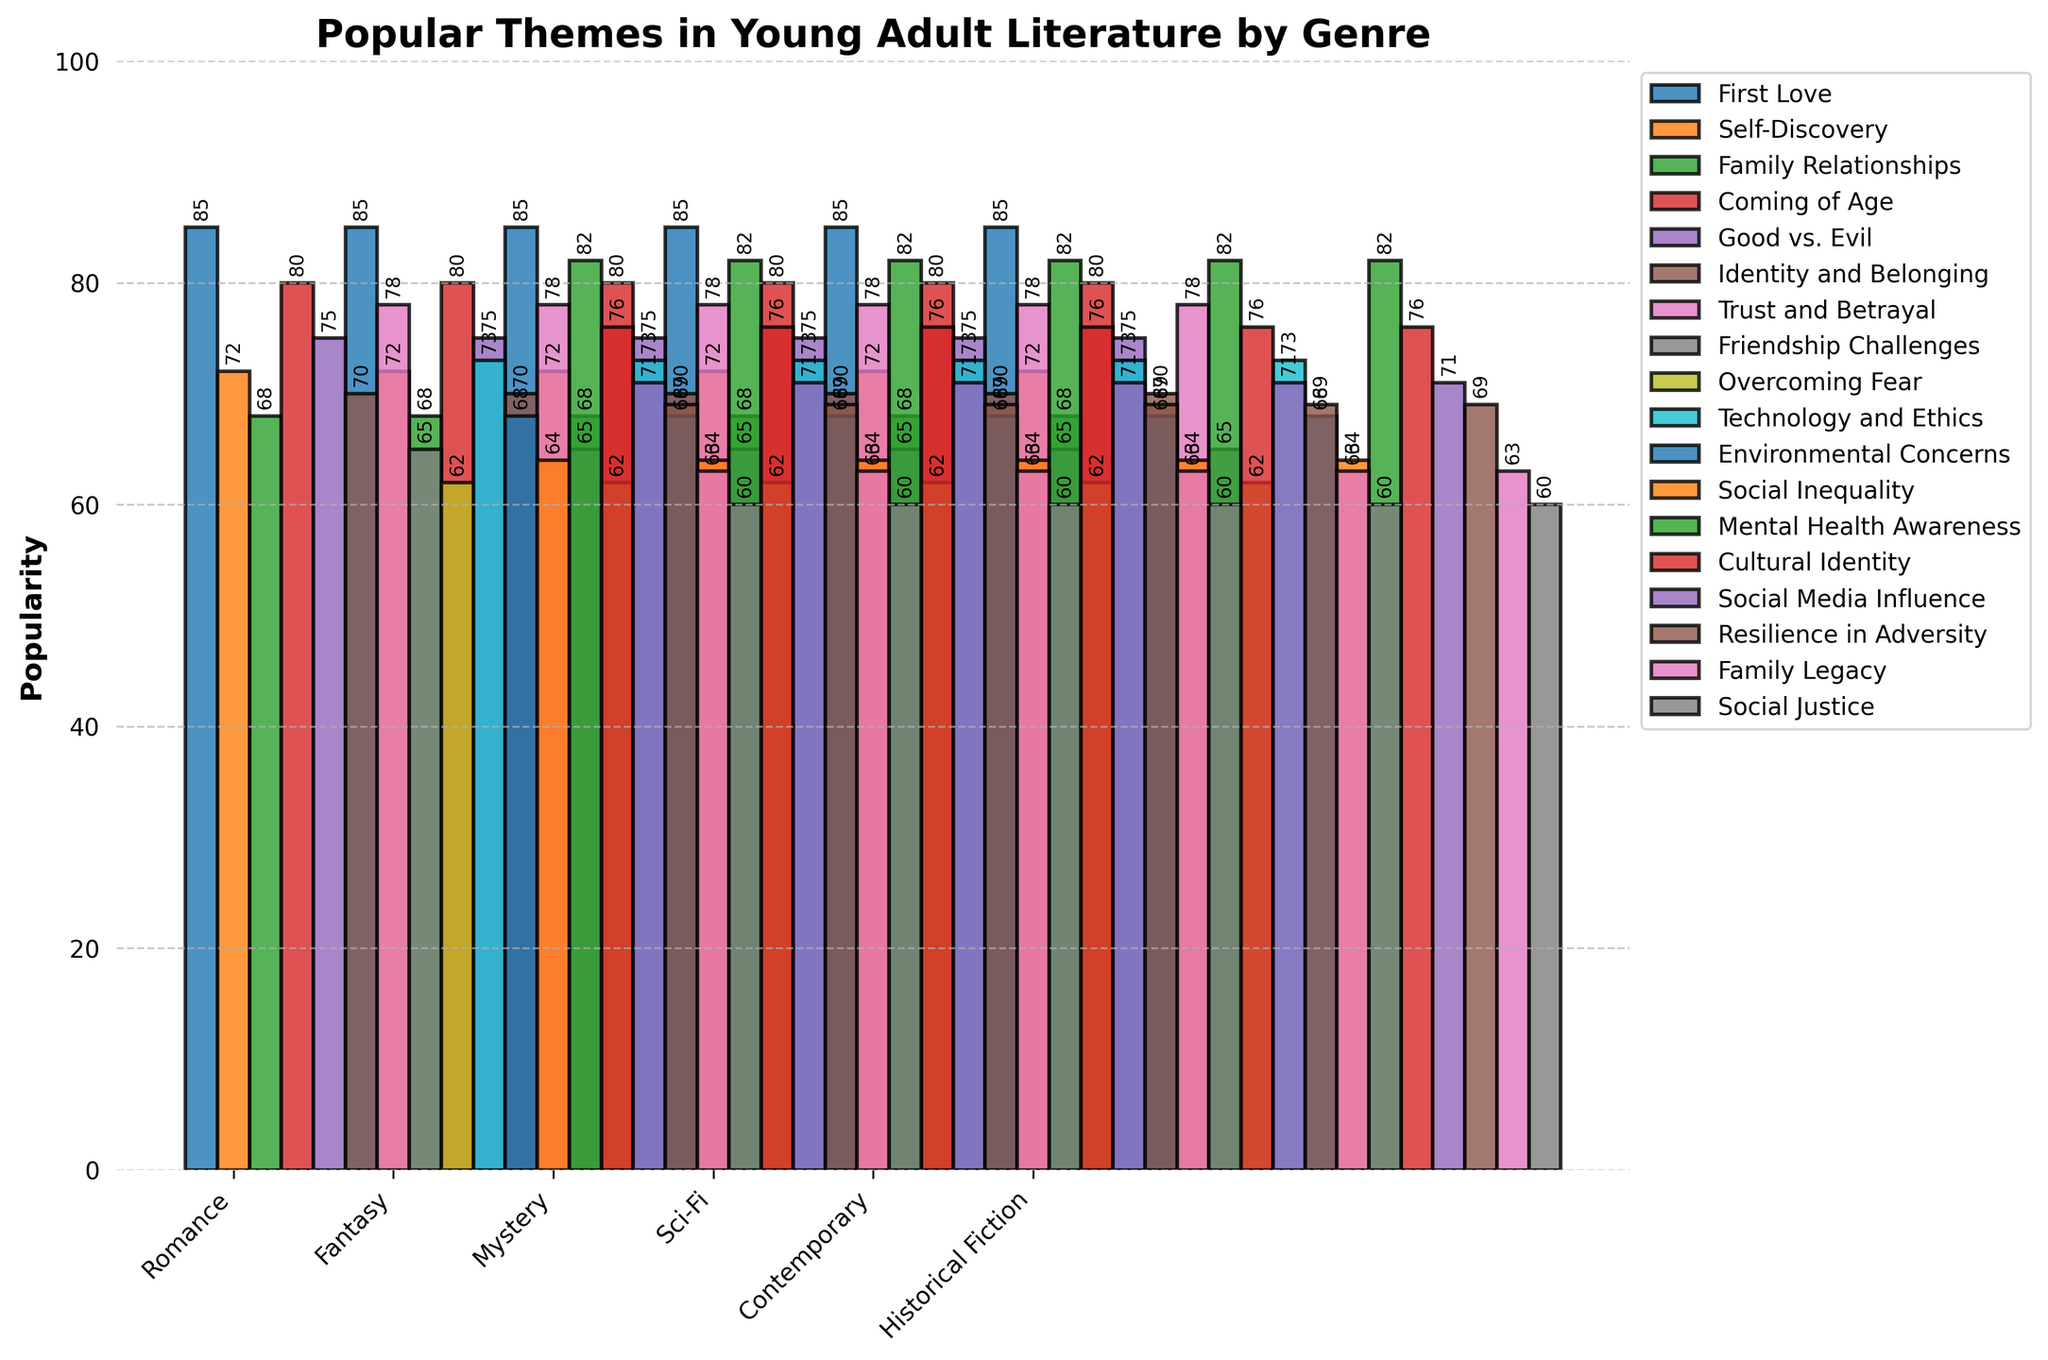Which theme in the 'Romance' genre has the highest popularity? First, identify the themes within the 'Romance' genre. From the data, 'First Love' has a popularity score of 85, 'Self-Discovery' has 72, and 'Family Relationships' has 68. 'First Love' has the highest popularity.
Answer: First Love Which genre has the most popular theme overall? Review the highest popularity scores for each genre: 'First Love' in Romance (85), 'Coming of Age' in Fantasy (80), 'Trust and Betrayal' in Mystery (78), 'Technology and Ethics' in Sci-Fi (73), 'Mental Health Awareness' in Contemporary (82), and 'Resilience in Adversity' in Historical Fiction (69). The highest score is 85 for the 'Romance' genre.
Answer: Romance What is the total popularity of all themes in the 'Mystery' genre? Sum the popularity scores for the 'Mystery' genre themes: 'Trust and Betrayal' (78) + 'Friendship Challenges' (65) + 'Overcoming Fear' (62) = 205.
Answer: 205 Which genre has the least popular theme, and what is it? Identify the lowest popularity scores across genres. 'Social Justice' in Historical Fiction has the lowest score of 60. Therefore, the genre is 'Historical Fiction', and the theme is 'Social Justice'.
Answer: Historical Fiction, Social Justice Between 'Fantasy' and 'Sci-Fi' genres, which has a higher average popularity of themes? Calculate the average popularity for each genre: 
Fantasy: (80 + 75 + 70) / 3 = 75, 
Sci-Fi: (73 + 68 + 64) / 3 = 68.33. 
'Fantasy' has the higher average.
Answer: Fantasy What is the difference in popularity between the most and least popular themes in the 'Contemporary' genre? The most popular theme in 'Contemporary' is 'Mental Health Awareness' (82), and the least popular is 'Social Media Influence' (71). The difference is 82 - 71 = 11.
Answer: 11 Which theme in the 'Historical Fiction' genre shows the second highest popularity? The popularity scores for 'Historical Fiction' themes are: 'Resilience in Adversity' (69), 'Family Legacy' (63), and 'Social Justice' (60). The second highest score is 63 for 'Family Legacy'.
Answer: Family Legacy Compare the 'Coming of Age' theme in 'Fantasy' and 'Self-Discovery' theme in 'Romance'. Which one is more popular? 'Coming of Age' in 'Fantasy' has a score of 80, and 'Self-Discovery' in 'Romance' has a score of 72. 'Coming of Age' in 'Fantasy' is more popular.
Answer: Coming of Age (Fantasy) Identify two themes with the closest popularity scores from different genres? From the data, 'Family Relationships' in Romance (68) and 'Environmental Concerns' in Sci-Fi (68) have the same popularity, making them the closest.
Answer: Family Relationships (Romance) and Environmental Concerns (Sci-Fi) 